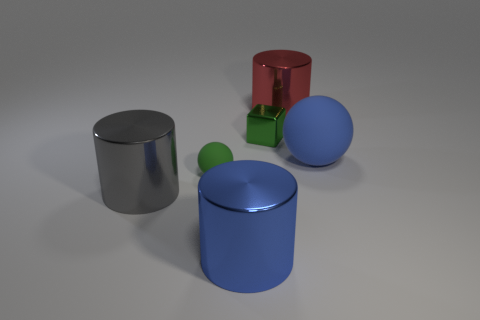Subtract all large gray metal cylinders. How many cylinders are left? 2 Subtract all green balls. How many balls are left? 1 Subtract all cubes. How many objects are left? 5 Subtract 1 blocks. How many blocks are left? 0 Add 4 large objects. How many objects exist? 10 Subtract 1 red cylinders. How many objects are left? 5 Subtract all purple spheres. Subtract all cyan blocks. How many spheres are left? 2 Subtract all green balls. How many yellow cylinders are left? 0 Subtract all green rubber balls. Subtract all gray metal cylinders. How many objects are left? 4 Add 5 gray objects. How many gray objects are left? 6 